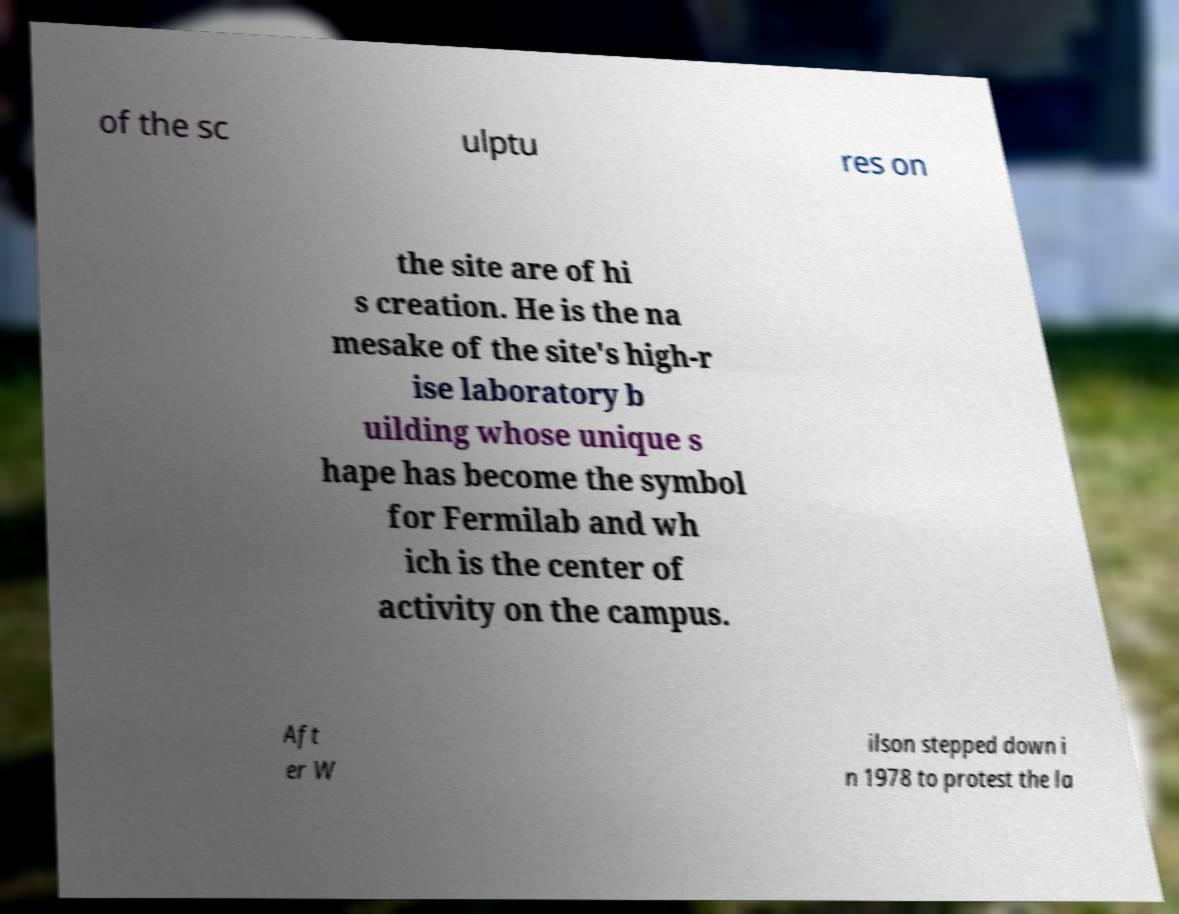What messages or text are displayed in this image? I need them in a readable, typed format. of the sc ulptu res on the site are of hi s creation. He is the na mesake of the site's high-r ise laboratory b uilding whose unique s hape has become the symbol for Fermilab and wh ich is the center of activity on the campus. Aft er W ilson stepped down i n 1978 to protest the la 